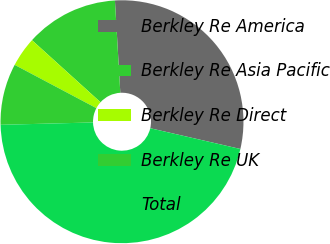Convert chart to OTSL. <chart><loc_0><loc_0><loc_500><loc_500><pie_chart><fcel>Berkley Re America<fcel>Berkley Re Asia Pacific<fcel>Berkley Re Direct<fcel>Berkley Re UK<fcel>Total<nl><fcel>29.53%<fcel>12.36%<fcel>3.96%<fcel>8.16%<fcel>45.99%<nl></chart> 